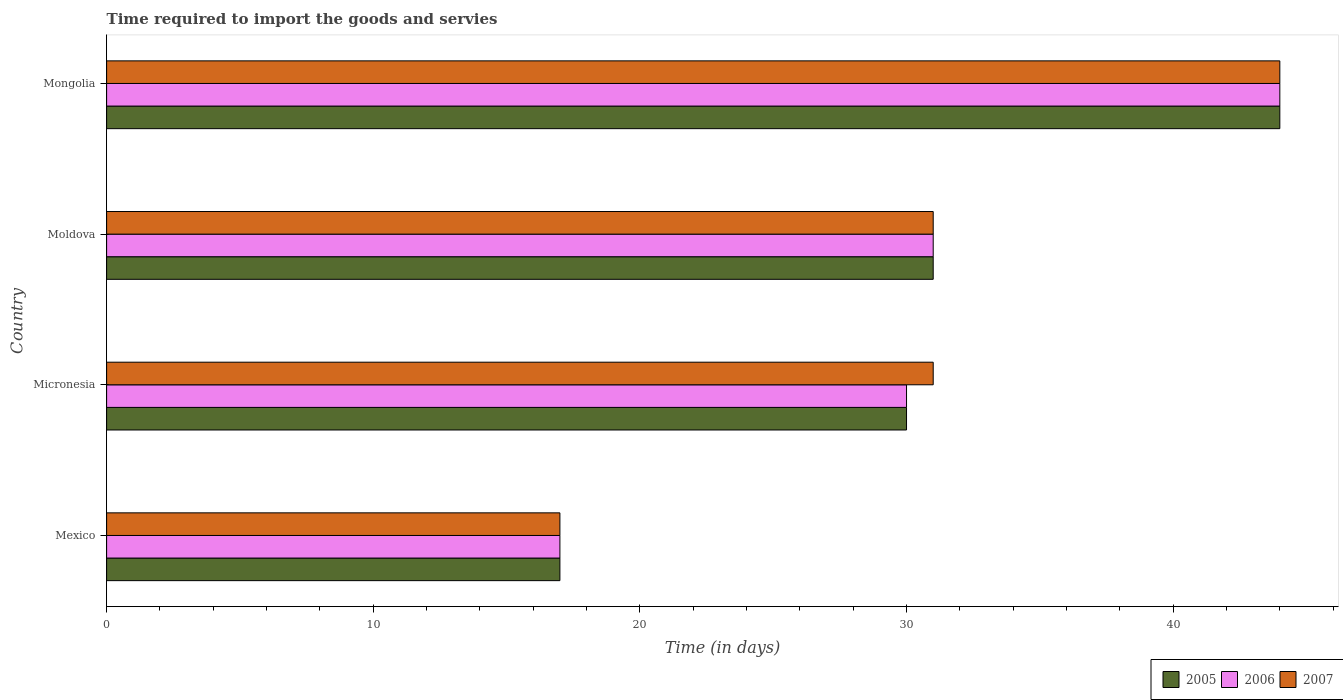How many groups of bars are there?
Keep it short and to the point. 4. Are the number of bars per tick equal to the number of legend labels?
Ensure brevity in your answer.  Yes. Are the number of bars on each tick of the Y-axis equal?
Your answer should be compact. Yes. How many bars are there on the 4th tick from the top?
Give a very brief answer. 3. How many bars are there on the 2nd tick from the bottom?
Ensure brevity in your answer.  3. What is the label of the 3rd group of bars from the top?
Your answer should be very brief. Micronesia. Across all countries, what is the minimum number of days required to import the goods and services in 2007?
Provide a succinct answer. 17. In which country was the number of days required to import the goods and services in 2007 maximum?
Offer a very short reply. Mongolia. What is the total number of days required to import the goods and services in 2005 in the graph?
Keep it short and to the point. 122. What is the difference between the number of days required to import the goods and services in 2006 in Micronesia and that in Moldova?
Offer a terse response. -1. What is the average number of days required to import the goods and services in 2006 per country?
Make the answer very short. 30.5. What is the difference between the number of days required to import the goods and services in 2005 and number of days required to import the goods and services in 2006 in Mongolia?
Your answer should be very brief. 0. What is the ratio of the number of days required to import the goods and services in 2006 in Moldova to that in Mongolia?
Your answer should be compact. 0.7. Is the difference between the number of days required to import the goods and services in 2005 in Mexico and Moldova greater than the difference between the number of days required to import the goods and services in 2006 in Mexico and Moldova?
Provide a short and direct response. No. What is the difference between the highest and the second highest number of days required to import the goods and services in 2006?
Provide a succinct answer. 13. In how many countries, is the number of days required to import the goods and services in 2005 greater than the average number of days required to import the goods and services in 2005 taken over all countries?
Offer a terse response. 2. Is the sum of the number of days required to import the goods and services in 2006 in Mexico and Mongolia greater than the maximum number of days required to import the goods and services in 2007 across all countries?
Keep it short and to the point. Yes. What does the 3rd bar from the top in Moldova represents?
Make the answer very short. 2005. How many bars are there?
Offer a very short reply. 12. Are the values on the major ticks of X-axis written in scientific E-notation?
Offer a very short reply. No. Where does the legend appear in the graph?
Give a very brief answer. Bottom right. How many legend labels are there?
Ensure brevity in your answer.  3. What is the title of the graph?
Offer a terse response. Time required to import the goods and servies. What is the label or title of the X-axis?
Offer a very short reply. Time (in days). What is the label or title of the Y-axis?
Your response must be concise. Country. What is the Time (in days) in 2005 in Mexico?
Offer a very short reply. 17. What is the Time (in days) in 2006 in Mexico?
Give a very brief answer. 17. What is the Time (in days) of 2007 in Mexico?
Offer a very short reply. 17. What is the Time (in days) in 2005 in Micronesia?
Give a very brief answer. 30. What is the Time (in days) in 2006 in Micronesia?
Provide a succinct answer. 30. What is the Time (in days) of 2007 in Micronesia?
Your answer should be compact. 31. What is the Time (in days) of 2005 in Moldova?
Your answer should be compact. 31. What is the Time (in days) in 2006 in Moldova?
Your response must be concise. 31. What is the Time (in days) of 2006 in Mongolia?
Ensure brevity in your answer.  44. Across all countries, what is the maximum Time (in days) in 2006?
Offer a very short reply. 44. Across all countries, what is the maximum Time (in days) of 2007?
Ensure brevity in your answer.  44. Across all countries, what is the minimum Time (in days) of 2005?
Give a very brief answer. 17. Across all countries, what is the minimum Time (in days) in 2006?
Your answer should be compact. 17. What is the total Time (in days) of 2005 in the graph?
Provide a short and direct response. 122. What is the total Time (in days) in 2006 in the graph?
Your answer should be very brief. 122. What is the total Time (in days) of 2007 in the graph?
Provide a short and direct response. 123. What is the difference between the Time (in days) in 2005 in Mexico and that in Micronesia?
Keep it short and to the point. -13. What is the difference between the Time (in days) in 2006 in Mexico and that in Micronesia?
Make the answer very short. -13. What is the difference between the Time (in days) of 2007 in Mexico and that in Micronesia?
Your answer should be very brief. -14. What is the difference between the Time (in days) in 2005 in Mexico and that in Moldova?
Provide a short and direct response. -14. What is the difference between the Time (in days) in 2005 in Mexico and that in Mongolia?
Your answer should be compact. -27. What is the difference between the Time (in days) in 2006 in Mexico and that in Mongolia?
Give a very brief answer. -27. What is the difference between the Time (in days) in 2007 in Mexico and that in Mongolia?
Give a very brief answer. -27. What is the difference between the Time (in days) in 2006 in Micronesia and that in Moldova?
Make the answer very short. -1. What is the difference between the Time (in days) in 2007 in Micronesia and that in Moldova?
Offer a very short reply. 0. What is the difference between the Time (in days) of 2005 in Micronesia and that in Mongolia?
Your answer should be compact. -14. What is the difference between the Time (in days) of 2007 in Micronesia and that in Mongolia?
Give a very brief answer. -13. What is the difference between the Time (in days) in 2005 in Moldova and that in Mongolia?
Keep it short and to the point. -13. What is the difference between the Time (in days) of 2006 in Moldova and that in Mongolia?
Make the answer very short. -13. What is the difference between the Time (in days) of 2007 in Moldova and that in Mongolia?
Provide a short and direct response. -13. What is the difference between the Time (in days) of 2005 in Mexico and the Time (in days) of 2006 in Micronesia?
Provide a short and direct response. -13. What is the difference between the Time (in days) of 2005 in Mexico and the Time (in days) of 2007 in Micronesia?
Give a very brief answer. -14. What is the difference between the Time (in days) of 2005 in Mexico and the Time (in days) of 2006 in Moldova?
Your answer should be compact. -14. What is the difference between the Time (in days) in 2005 in Mexico and the Time (in days) in 2006 in Mongolia?
Make the answer very short. -27. What is the difference between the Time (in days) in 2005 in Micronesia and the Time (in days) in 2006 in Moldova?
Your response must be concise. -1. What is the difference between the Time (in days) of 2005 in Micronesia and the Time (in days) of 2007 in Moldova?
Your answer should be compact. -1. What is the difference between the Time (in days) of 2006 in Micronesia and the Time (in days) of 2007 in Mongolia?
Your answer should be very brief. -14. What is the average Time (in days) in 2005 per country?
Offer a terse response. 30.5. What is the average Time (in days) in 2006 per country?
Your answer should be compact. 30.5. What is the average Time (in days) in 2007 per country?
Provide a short and direct response. 30.75. What is the difference between the Time (in days) in 2005 and Time (in days) in 2006 in Mexico?
Your answer should be very brief. 0. What is the difference between the Time (in days) of 2006 and Time (in days) of 2007 in Mexico?
Your answer should be very brief. 0. What is the difference between the Time (in days) of 2005 and Time (in days) of 2006 in Micronesia?
Keep it short and to the point. 0. What is the difference between the Time (in days) of 2005 and Time (in days) of 2007 in Micronesia?
Keep it short and to the point. -1. What is the difference between the Time (in days) of 2006 and Time (in days) of 2007 in Micronesia?
Offer a very short reply. -1. What is the difference between the Time (in days) in 2005 and Time (in days) in 2006 in Moldova?
Give a very brief answer. 0. What is the difference between the Time (in days) in 2005 and Time (in days) in 2007 in Moldova?
Make the answer very short. 0. What is the difference between the Time (in days) of 2005 and Time (in days) of 2007 in Mongolia?
Make the answer very short. 0. What is the difference between the Time (in days) in 2006 and Time (in days) in 2007 in Mongolia?
Your answer should be compact. 0. What is the ratio of the Time (in days) in 2005 in Mexico to that in Micronesia?
Give a very brief answer. 0.57. What is the ratio of the Time (in days) in 2006 in Mexico to that in Micronesia?
Ensure brevity in your answer.  0.57. What is the ratio of the Time (in days) of 2007 in Mexico to that in Micronesia?
Provide a succinct answer. 0.55. What is the ratio of the Time (in days) in 2005 in Mexico to that in Moldova?
Keep it short and to the point. 0.55. What is the ratio of the Time (in days) in 2006 in Mexico to that in Moldova?
Offer a terse response. 0.55. What is the ratio of the Time (in days) in 2007 in Mexico to that in Moldova?
Your answer should be compact. 0.55. What is the ratio of the Time (in days) in 2005 in Mexico to that in Mongolia?
Provide a succinct answer. 0.39. What is the ratio of the Time (in days) in 2006 in Mexico to that in Mongolia?
Your answer should be very brief. 0.39. What is the ratio of the Time (in days) in 2007 in Mexico to that in Mongolia?
Your answer should be very brief. 0.39. What is the ratio of the Time (in days) of 2005 in Micronesia to that in Moldova?
Keep it short and to the point. 0.97. What is the ratio of the Time (in days) in 2006 in Micronesia to that in Moldova?
Your answer should be very brief. 0.97. What is the ratio of the Time (in days) in 2005 in Micronesia to that in Mongolia?
Give a very brief answer. 0.68. What is the ratio of the Time (in days) in 2006 in Micronesia to that in Mongolia?
Your response must be concise. 0.68. What is the ratio of the Time (in days) in 2007 in Micronesia to that in Mongolia?
Give a very brief answer. 0.7. What is the ratio of the Time (in days) of 2005 in Moldova to that in Mongolia?
Offer a very short reply. 0.7. What is the ratio of the Time (in days) of 2006 in Moldova to that in Mongolia?
Give a very brief answer. 0.7. What is the ratio of the Time (in days) in 2007 in Moldova to that in Mongolia?
Make the answer very short. 0.7. What is the difference between the highest and the lowest Time (in days) of 2006?
Your answer should be compact. 27. What is the difference between the highest and the lowest Time (in days) in 2007?
Your response must be concise. 27. 